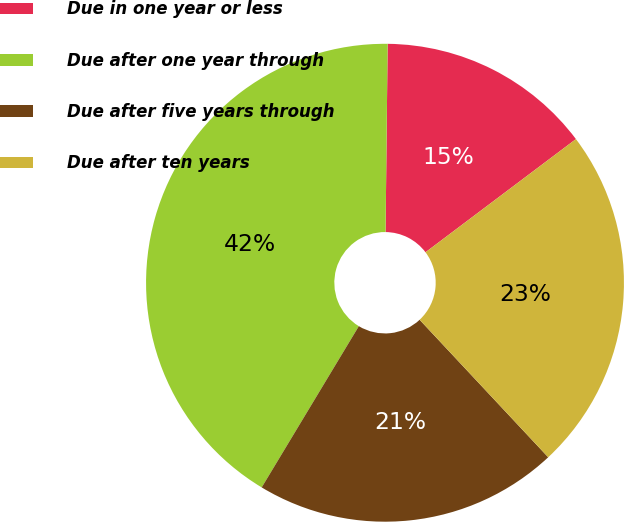Convert chart to OTSL. <chart><loc_0><loc_0><loc_500><loc_500><pie_chart><fcel>Due in one year or less<fcel>Due after one year through<fcel>Due after five years through<fcel>Due after ten years<nl><fcel>14.56%<fcel>41.55%<fcel>20.6%<fcel>23.3%<nl></chart> 